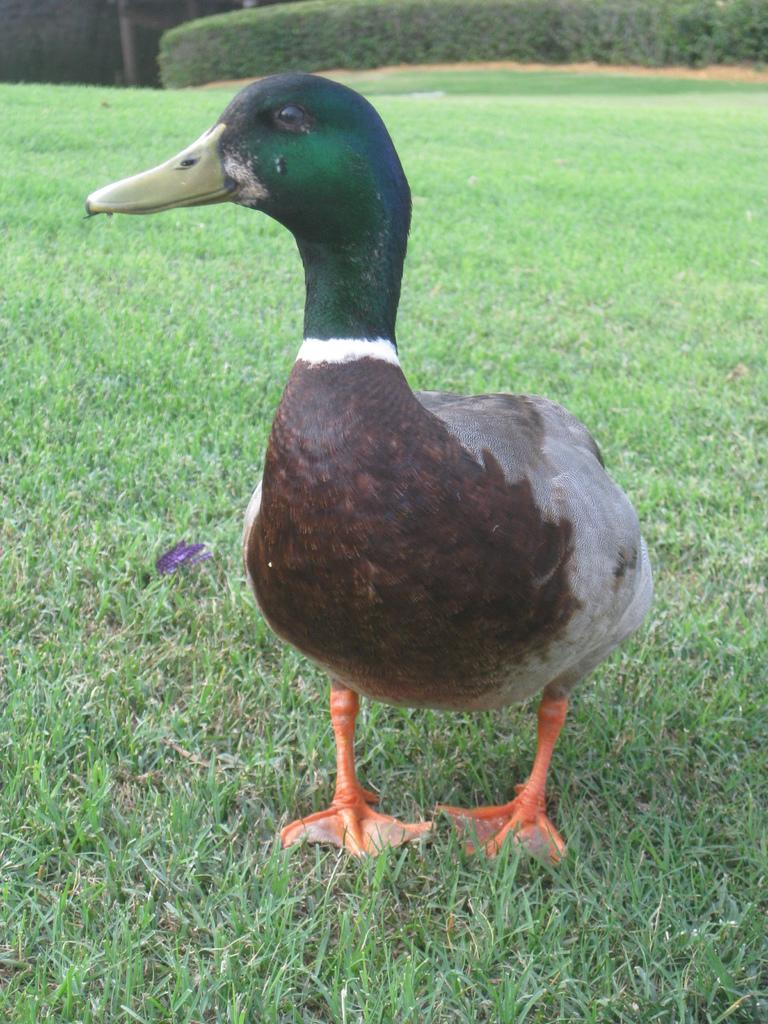What type of animal can be seen in the image? There is a bird in the image. Where is the bird located? The bird is on the ground. In which direction is the bird looking? The bird is looking to the left side. What type of vegetation is visible in the image? There is grass visible in the image. What can be seen in the background of the image? There are plants in the background of the image. What type of bun is being used as an apparatus for the bird in the image? There is no bun or apparatus present in the image; it features a bird on the ground looking to the left side. 